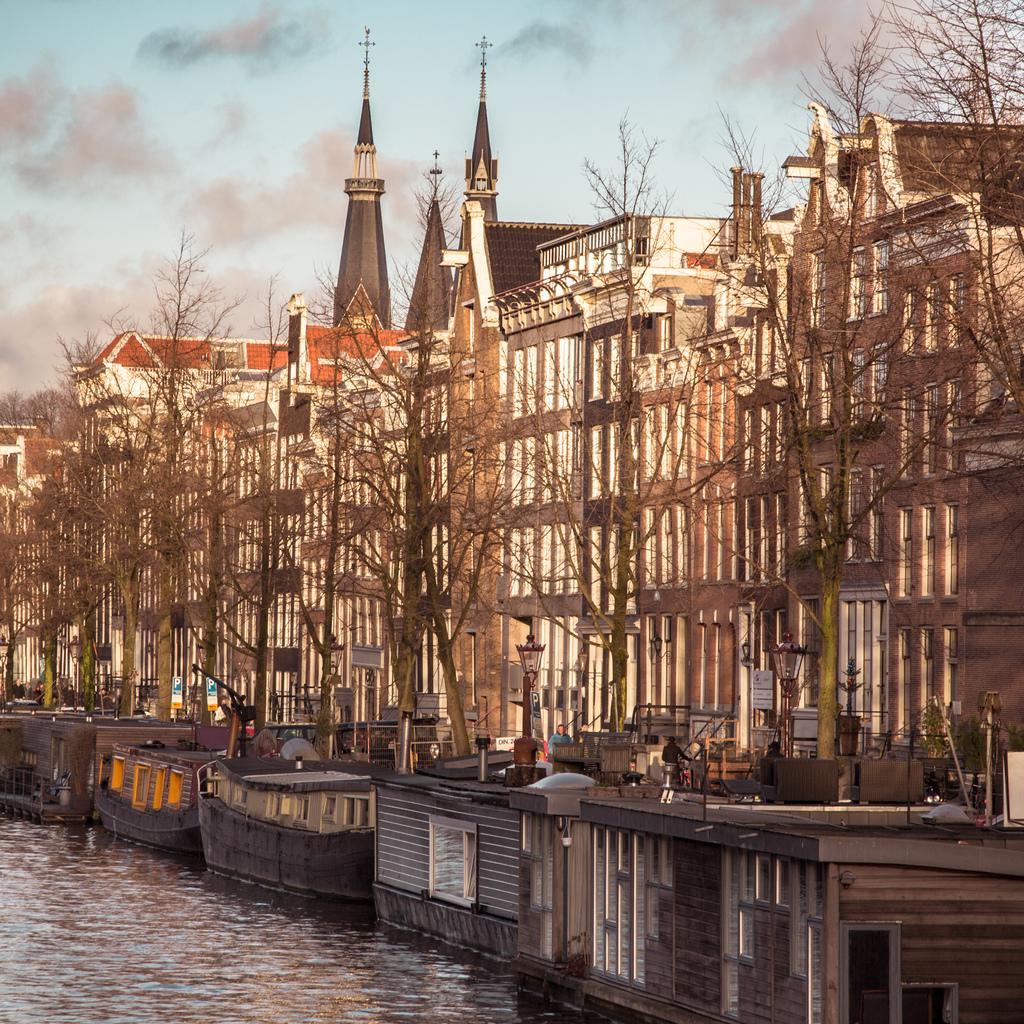Could you give a brief overview of what you see in this image? In this picture we can see the sky. On the right side of the picture we can see the buildings, at the top we can see the holy cross symbols. In this picture we can see the trees, plants, board, people, boats, lights and the water. 